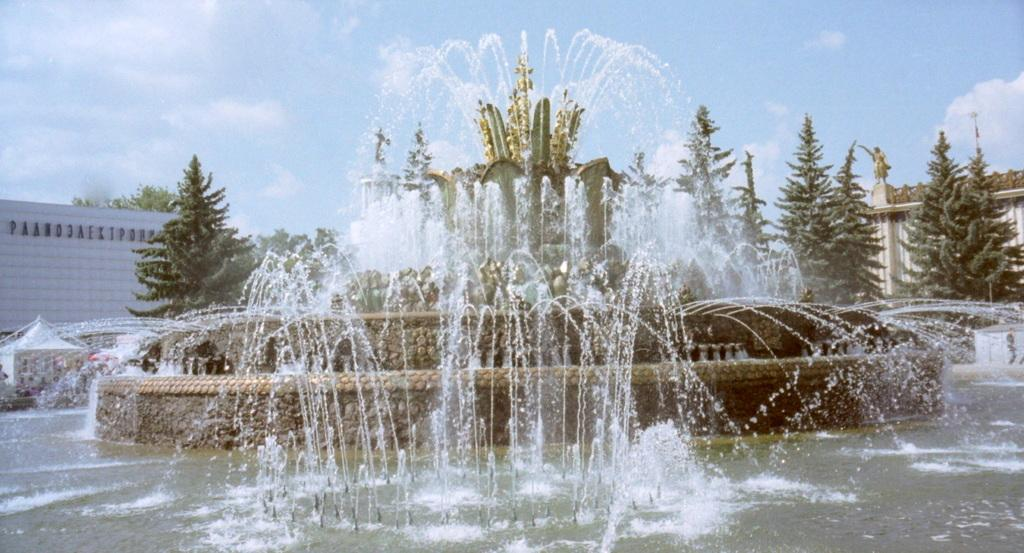What is the primary element in the image? There is water in the image. What structure is present in the water? There is a fountain in the image. What type of vegetation can be seen in the image? There are trees in the image. What architectural features are present in the image? There are walls in the image. What else can be seen in the image besides the water, fountain, trees, and walls? There are some objects in the image. What is visible in the background of the image? The sky is visible in the background of the image. How does the water in the image start the digestion process? The water in the image does not have any direct impact on the digestion process. 